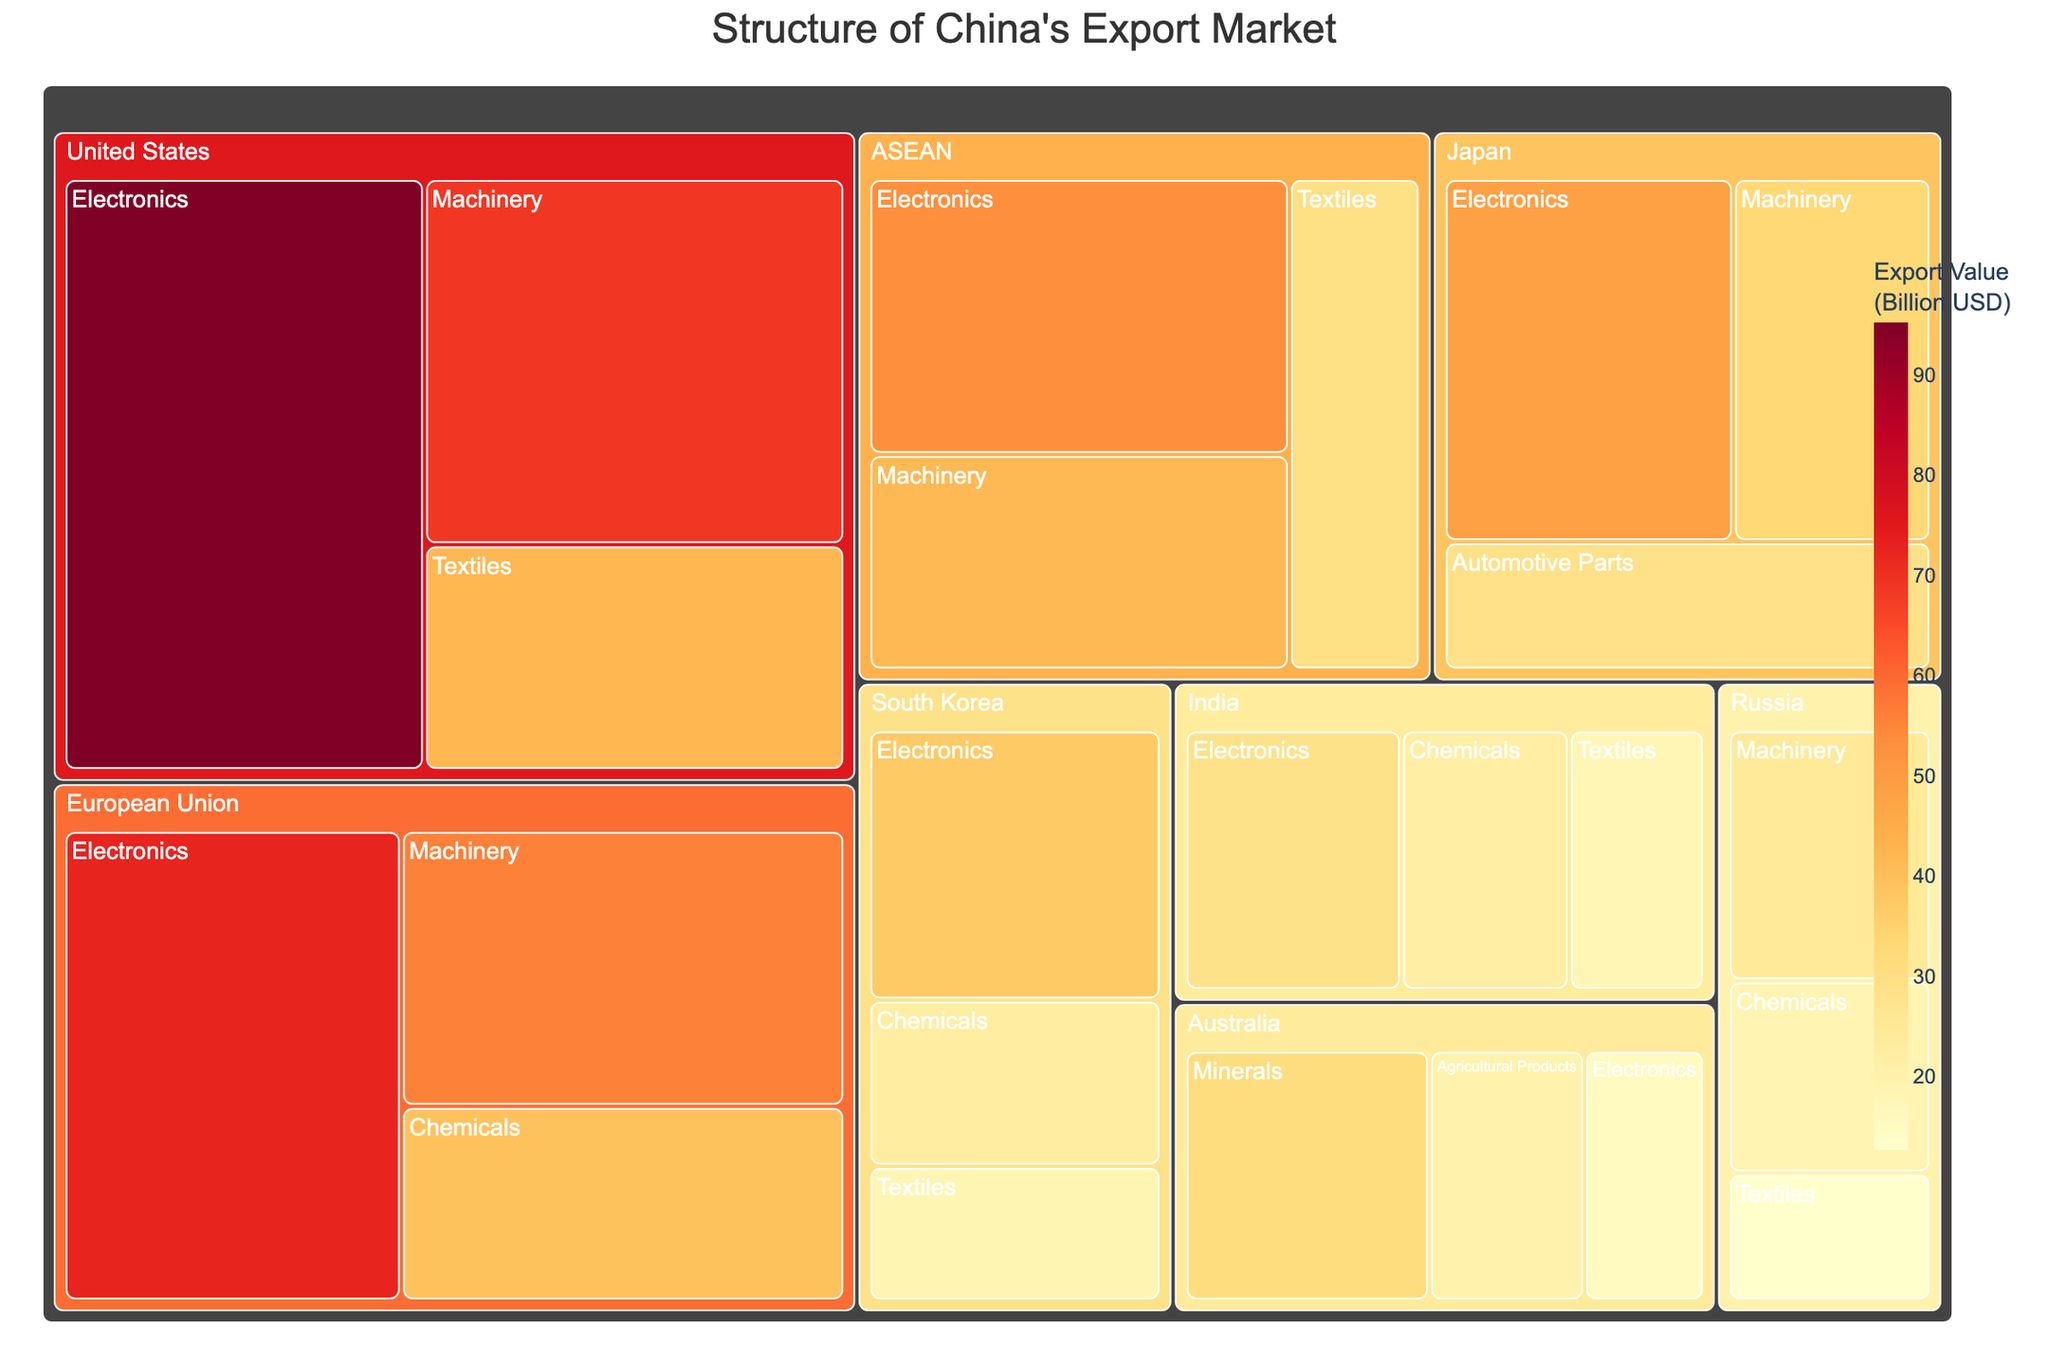What is the title of the treemap? The title is displayed at the top of the figure. It provides an overview of what the figure represents.
Answer: Structure of China's Export Market Which country has the highest export value in Electronics? Look for the country section with the largest block representing Electronics. The country's name is labeled on the block.
Answer: United States What is the total export value for Machinery products? Sum the export values of Machinery for all countries. The values are found within the figure.
Answer: 224.2 billion USD How does the export value of Chemicals to Russia compare to that to India? Identify the sections for Chemicals under Russia and India, then compare their sizes and export values.
Answer: Russia: 18.9 billion USD, India: 22.1 billion USD. So, India has a higher value What are the top three export destinations by overall export value? Sum the export values for all products within each country and identify the top three countries with the highest totals.
Answer: United States, European Union, ASEAN Which product type has the least export value to South Korea? Look at the sections under South Korea and identify the product with the smallest block.
Answer: Textiles What is the average export value of Textiles across all countries? Sum the export values of Textiles for all countries and divide by the number of countries exporting Textiles (4).
Answer: (42.3 + 18.5 + 29.6 + 12.6 + 17.8) / 5 = 24.16 billion USD In which product category does China export the most to ASEAN? Identify the largest block under ASEAN and check the label for the product type.
Answer: Electronics How much more does China export in Electronics to the United States compared to Japan? Subtract Japan's Electronics export value from the United States' Electronics export value.
Answer: 95.2 - 48.6 = 46.6 billion USD Which product category contributes most significantly to China's export to Australia? Look at the blocks under Australia and identify the largest one.
Answer: Minerals 